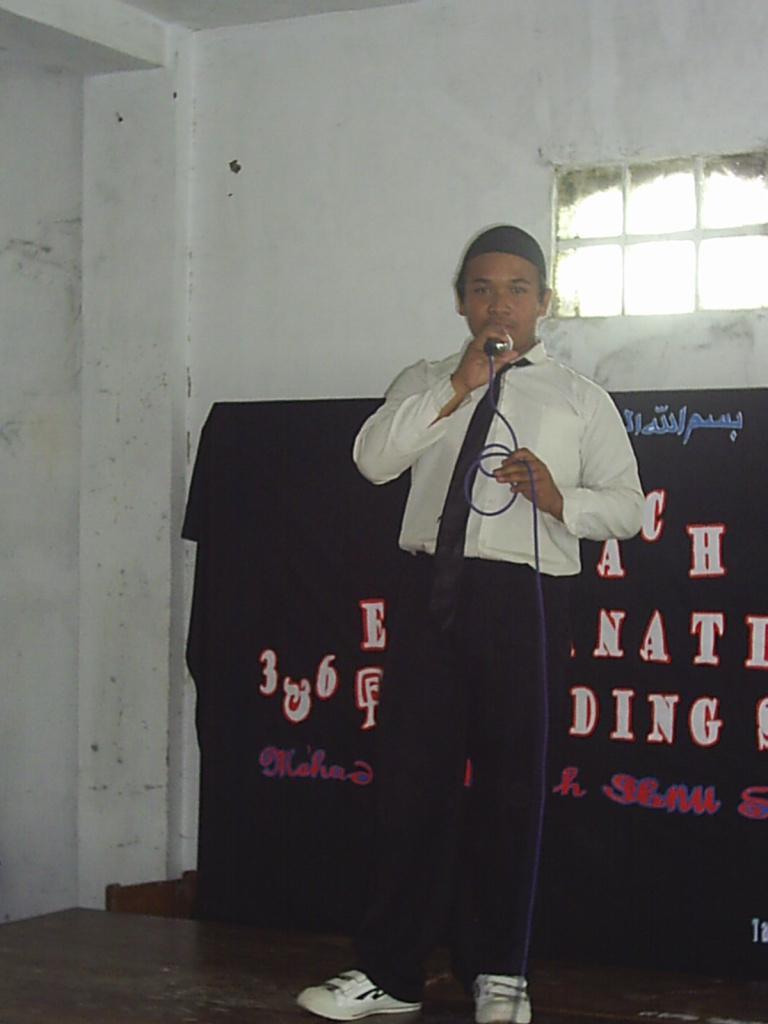Please provide a concise description of this image. In the middle of the image we can see a man, he is holding a microphone, behind him we can see some text. 